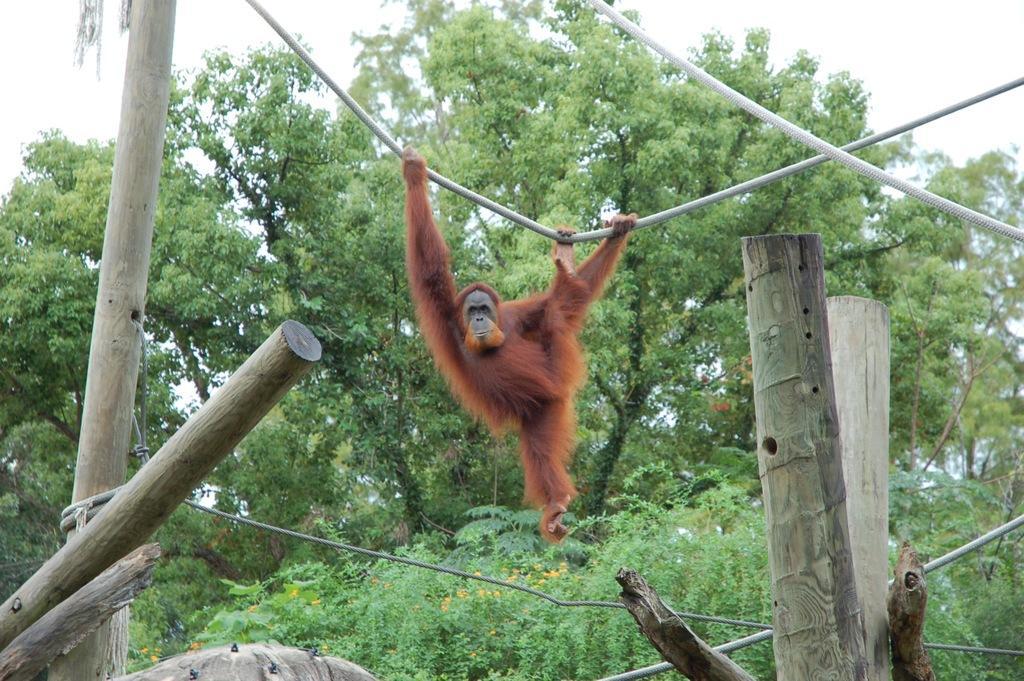How would you summarize this image in a sentence or two? In the center of the picture there is a monkey hanging to a rope. In the foreground of the picture there are wooden logs. In the background there are trees and flowers. Sky is cloudy. 